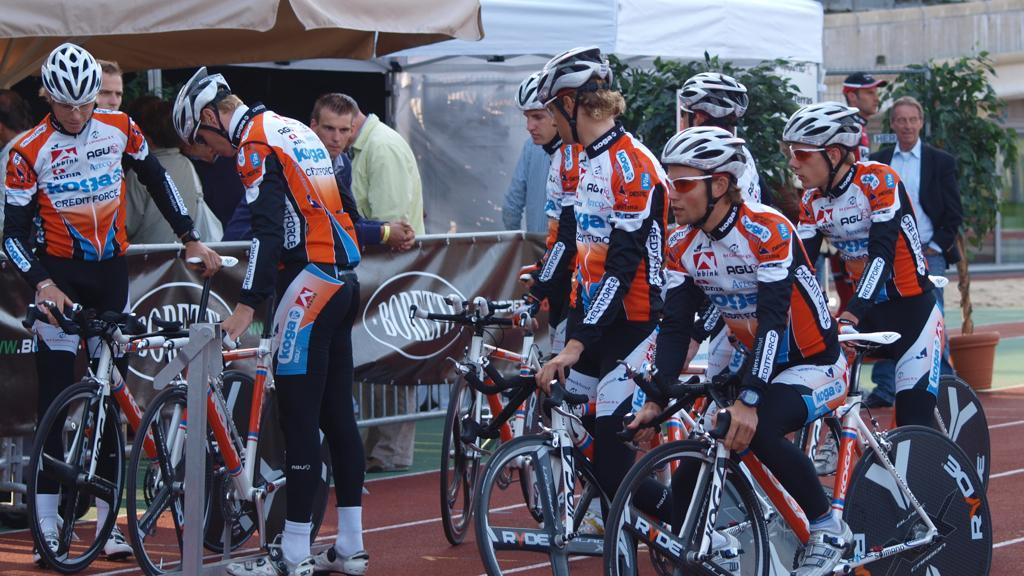How would you summarize this image in a sentence or two? In this image we can see a few people, some of them are riding bicycles, there are some tents, a building, plants, a pole, also we can see barricades, and posters with some text on it. 